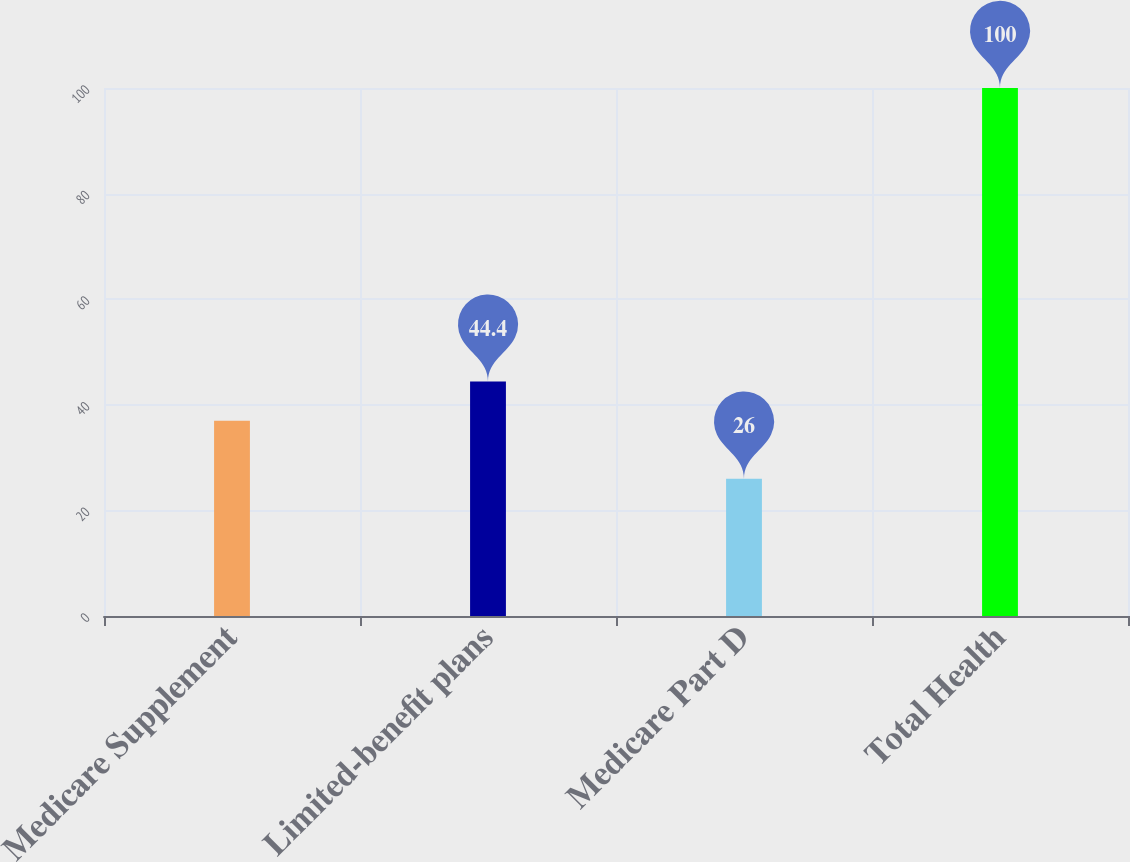Convert chart to OTSL. <chart><loc_0><loc_0><loc_500><loc_500><bar_chart><fcel>Medicare Supplement<fcel>Limited-benefit plans<fcel>Medicare Part D<fcel>Total Health<nl><fcel>37<fcel>44.4<fcel>26<fcel>100<nl></chart> 